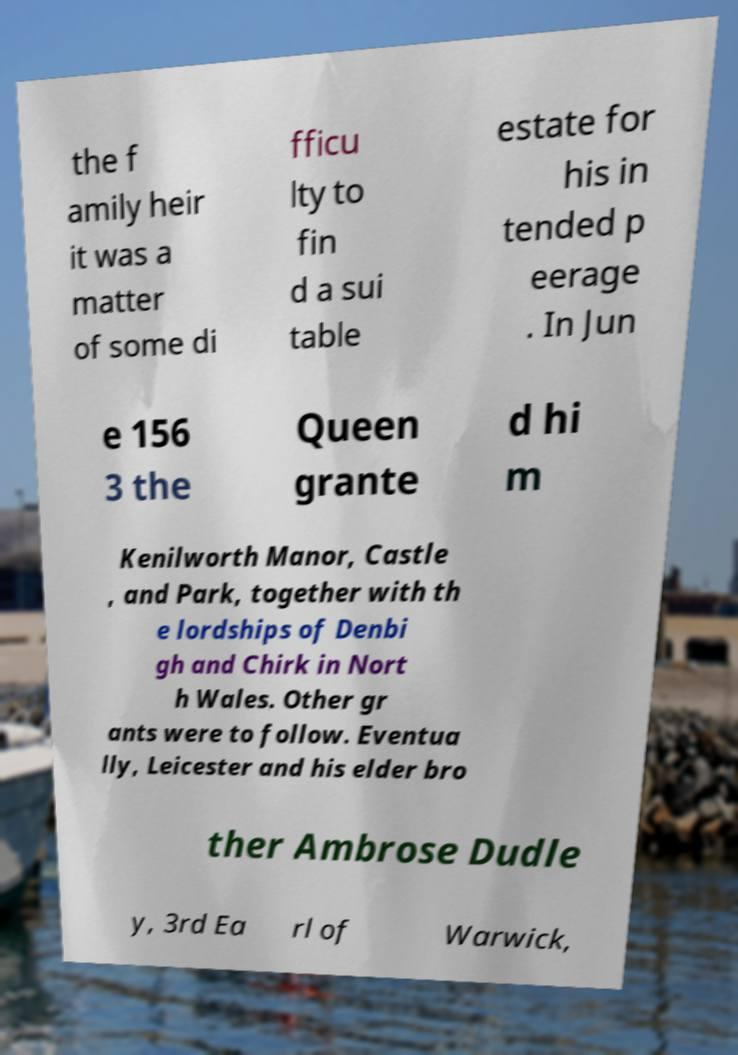Could you assist in decoding the text presented in this image and type it out clearly? the f amily heir it was a matter of some di fficu lty to fin d a sui table estate for his in tended p eerage . In Jun e 156 3 the Queen grante d hi m Kenilworth Manor, Castle , and Park, together with th e lordships of Denbi gh and Chirk in Nort h Wales. Other gr ants were to follow. Eventua lly, Leicester and his elder bro ther Ambrose Dudle y, 3rd Ea rl of Warwick, 